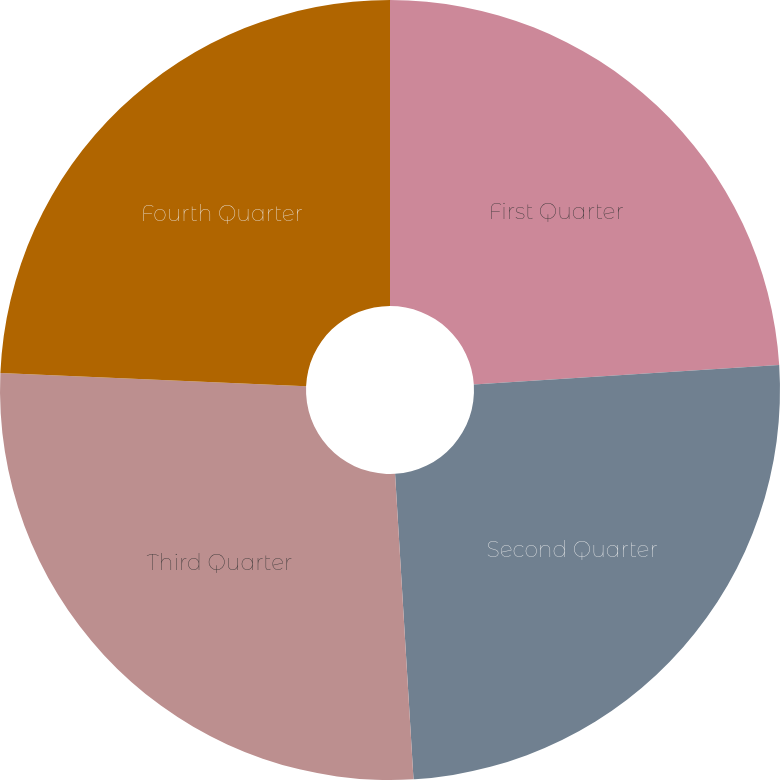Convert chart. <chart><loc_0><loc_0><loc_500><loc_500><pie_chart><fcel>First Quarter<fcel>Second Quarter<fcel>Third Quarter<fcel>Fourth Quarter<nl><fcel>23.98%<fcel>25.06%<fcel>26.65%<fcel>24.31%<nl></chart> 